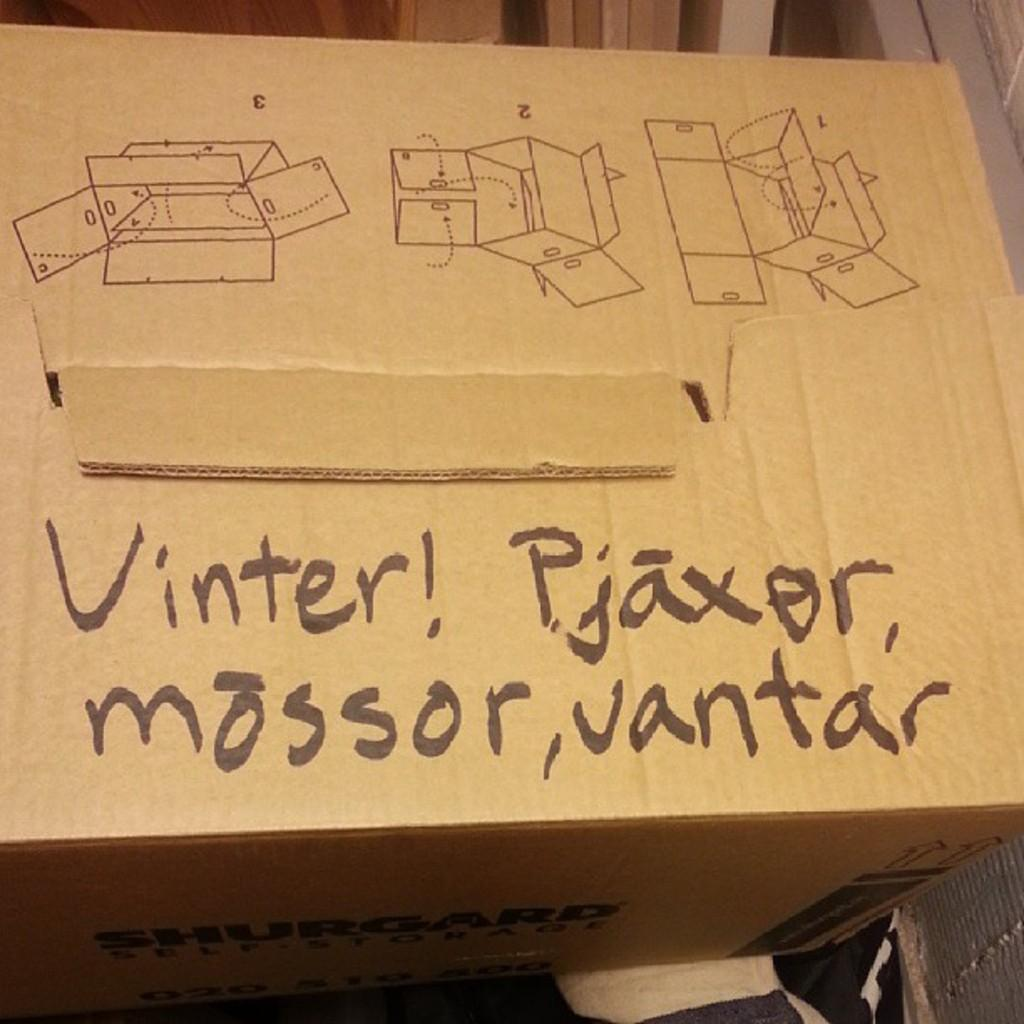<image>
Share a concise interpretation of the image provided. A cardboard box with the words Vinter Pjaxor, mossor, vantar, written on the top. 